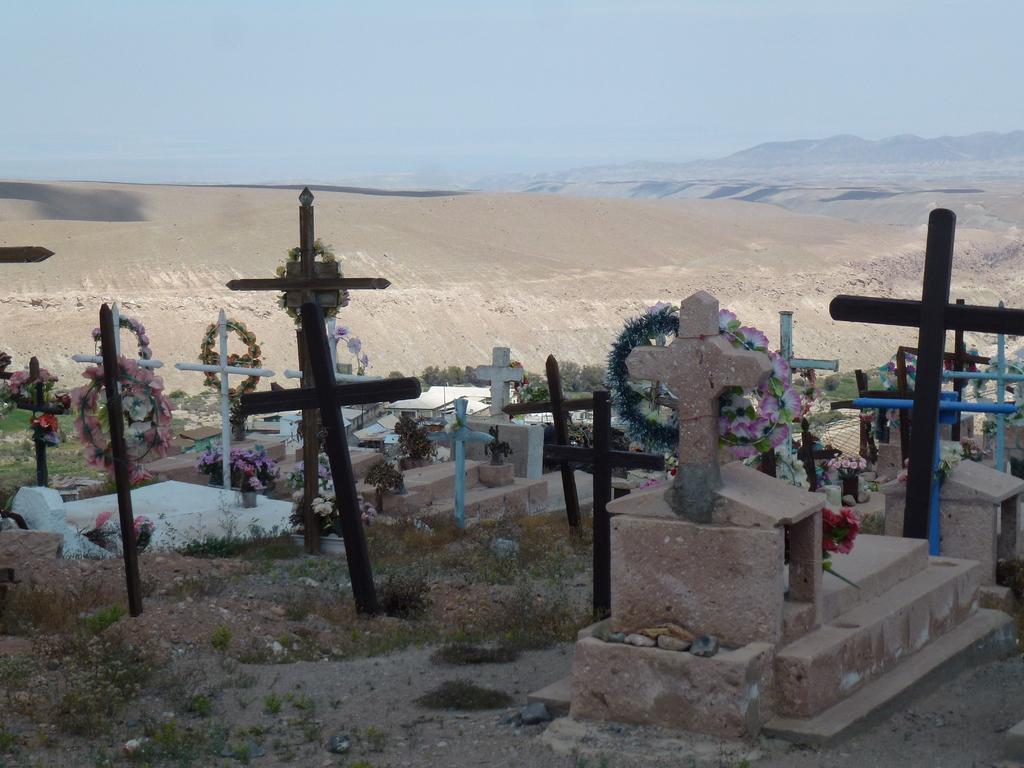Describe this image in one or two sentences. There is a graveyard which has few cross symbols on it. 